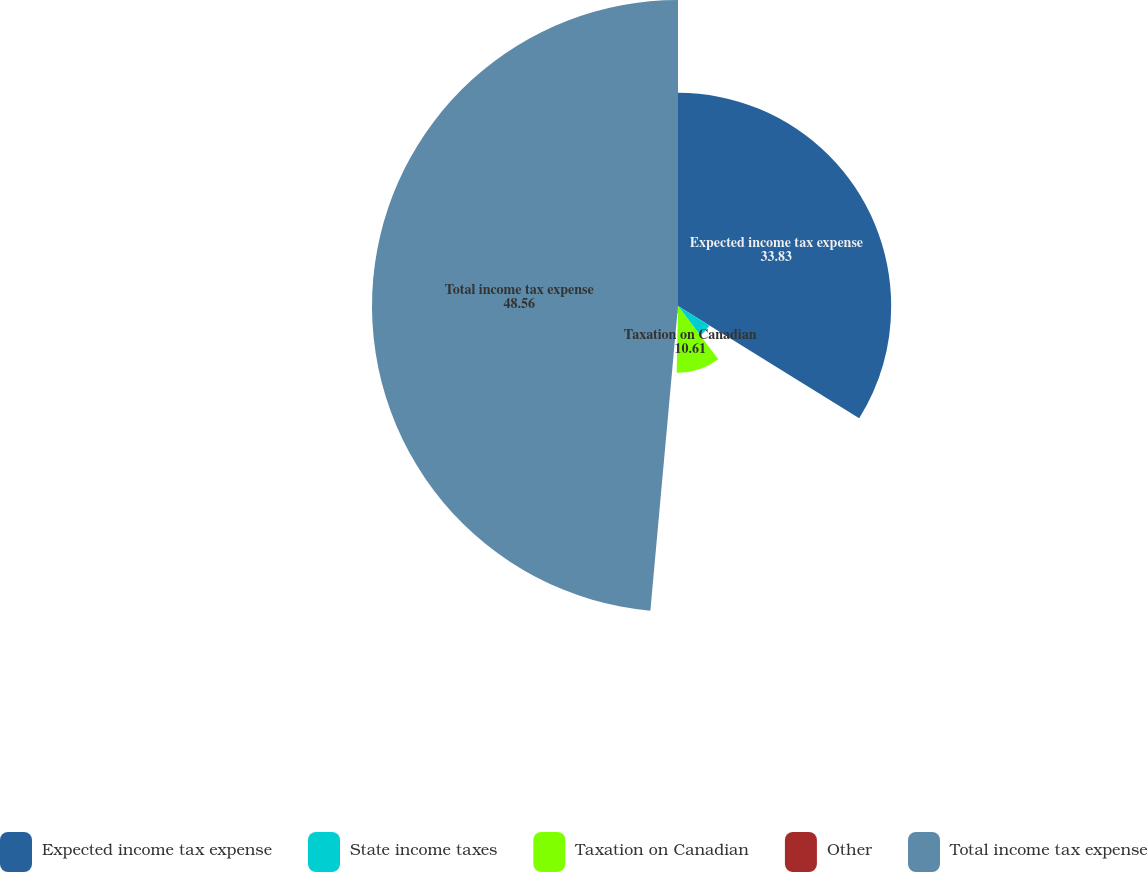Convert chart to OTSL. <chart><loc_0><loc_0><loc_500><loc_500><pie_chart><fcel>Expected income tax expense<fcel>State income taxes<fcel>Taxation on Canadian<fcel>Other<fcel>Total income tax expense<nl><fcel>33.83%<fcel>5.87%<fcel>10.61%<fcel>1.13%<fcel>48.56%<nl></chart> 